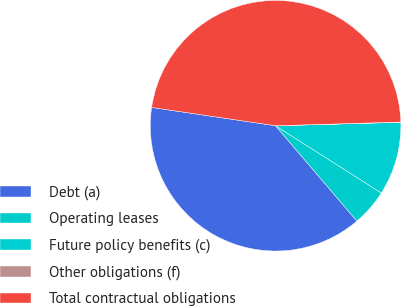<chart> <loc_0><loc_0><loc_500><loc_500><pie_chart><fcel>Debt (a)<fcel>Operating leases<fcel>Future policy benefits (c)<fcel>Other obligations (f)<fcel>Total contractual obligations<nl><fcel>38.58%<fcel>4.74%<fcel>9.46%<fcel>0.03%<fcel>47.2%<nl></chart> 